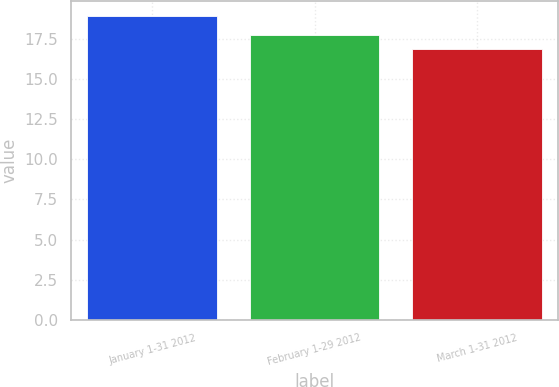<chart> <loc_0><loc_0><loc_500><loc_500><bar_chart><fcel>January 1-31 2012<fcel>February 1-29 2012<fcel>March 1-31 2012<nl><fcel>18.92<fcel>17.78<fcel>16.86<nl></chart> 